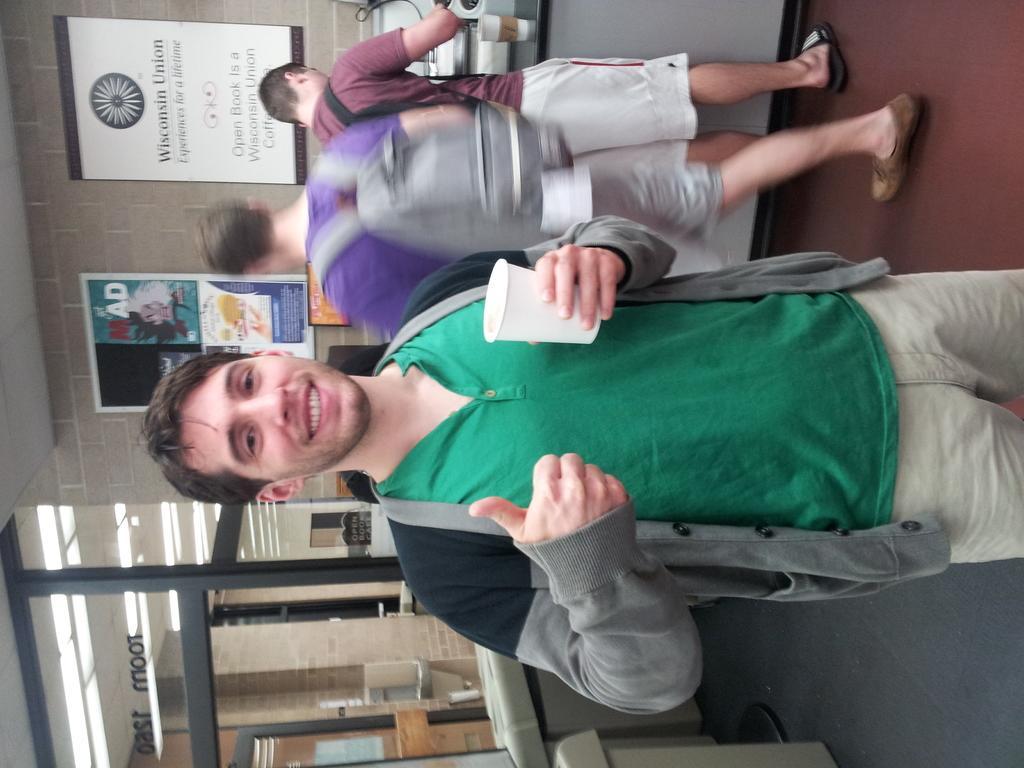How would you summarize this image in a sentence or two? The picture is taken inside an organisation,it is a tilted picture there is a man standing in the front and he is holding a cup in his hand and he is showing the thumbs up impression with his hand and he is smiling. Behind this person there are another two men and in the left side there is a door. 